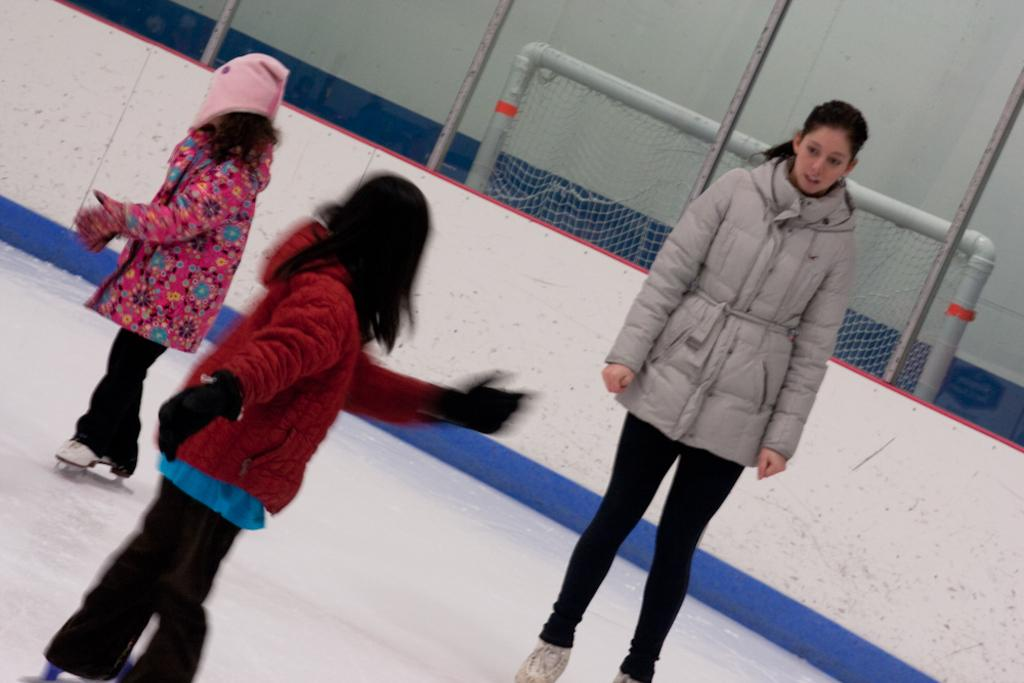Who is present in the image? There is a woman and two kids in the image. What are the people in the image standing on? The people are standing on ice. What type of clothing are the woman and kids wearing? They are wearing jackets, pants, and ice skates. What can be seen in the background of the image? There is a net and a wall in the image. What type of sweater is the woman wearing in the image? There is no mention of a sweater in the image. --- Facts: 1. There is a car in the image. 2. The car is red. 3. The car has four wheels. 4. The car has a sunroof. 5. The car has a black interior. 6. The car is parked in front of a house. Absurd Topics: bicycle, bird, treehouse Conversation: What is the main subject in the image? There is a car in the image. What color is the car? The car is red. How many wheels does the car have? The car has four wheels. What special feature does the car have? The car has a sunroof. What is the interior color of the car? The car has a black interior. Where is the car located in the image? The car is parked in front of a house. Reasoning: Let's think step by step in order to produce the conversation. We start by identifying the main subject of the image, which is the car. Next, we describe specific features of the car, such as its color, the number of wheels it has, and its special features, like the sunroof. Then, we mention the interior color of the car. Finally, we describe the location of the car in the image, which is parked in front of a house. Absurd Question/Answer: How many birds can be seen sitting on the car's sunroof in the image? There are no birds visible on the car's sunroof in the image. 